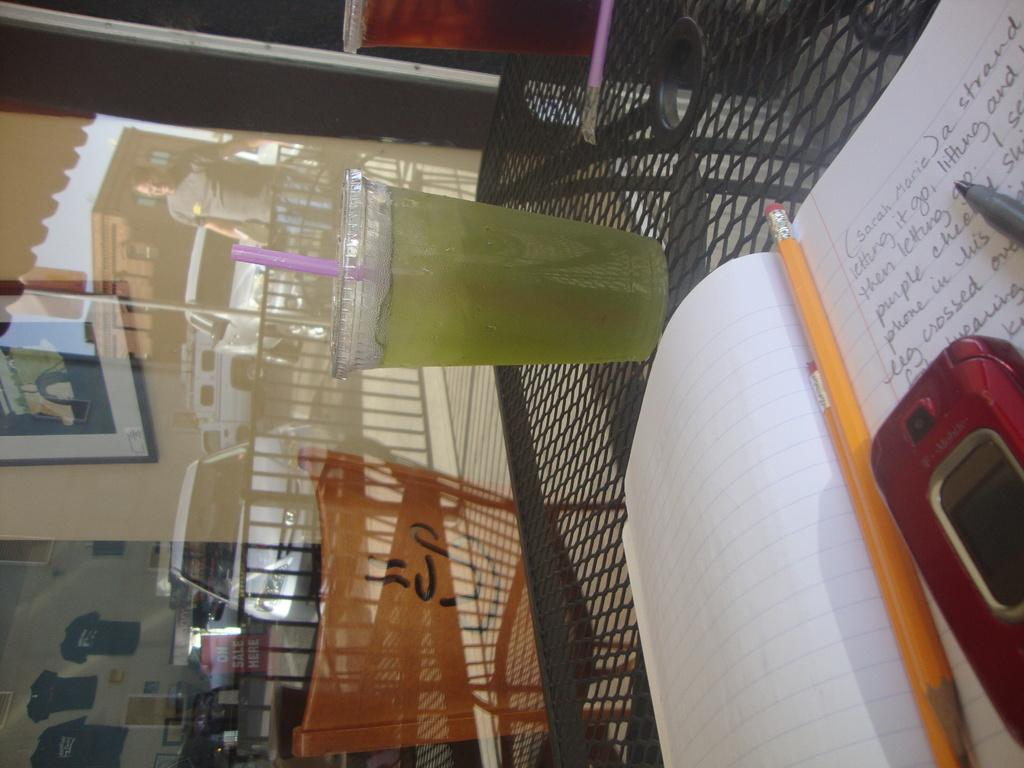<image>
Describe the image concisely. A notebook on a table open to a page that begins Sarah Marie. 